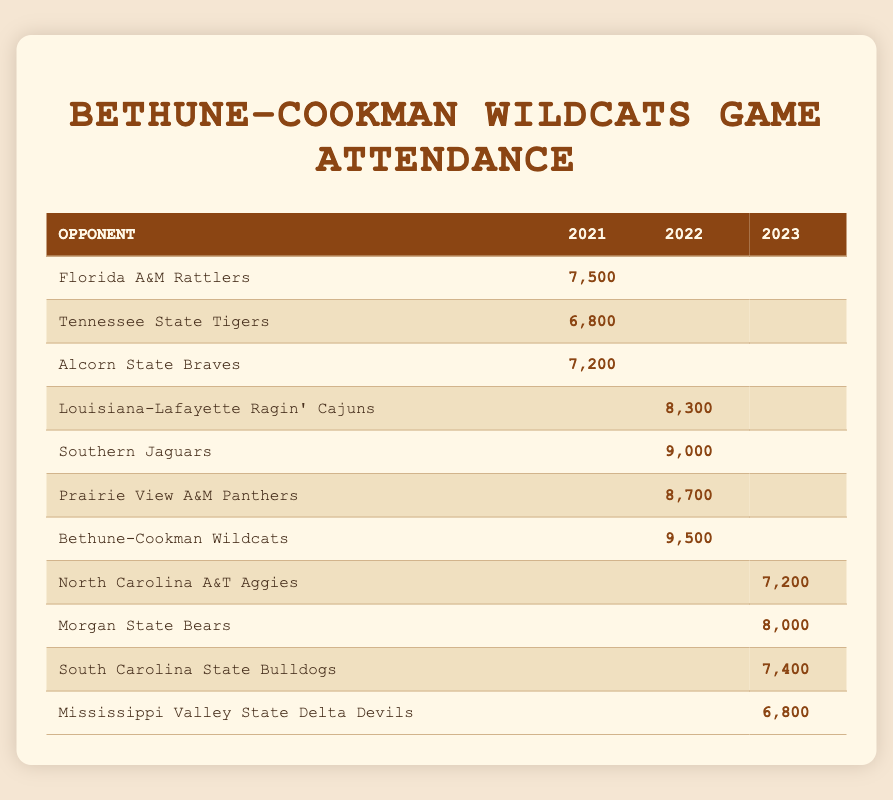What is the highest game attendance recorded in 2022? In the 2022 season, the attendance figures are 8,300 (Louisiana-Lafayette), 9,000 (Southern), 8,700 (Prairie View A&M), and 9,500 (Bethune-Cookman). The maximum attendance among these values is 9,500.
Answer: 9,500 Which opponent had the lowest attendance in 2021? Examining the 2021 attendance values, we have 7,500 (Florida A&M), 6,800 (Tennessee State), and 7,200 (Alcorn State). The lowest is 6,800 for Tennessee State.
Answer: 6,800 Calculate the average attendance across all games played in 2023. The attendances for 2023 are 7,200 (North Carolina A&T), 8,000 (Morgan State), 7,400 (South Carolina State), and 6,800 (Mississippi Valley State). Summing these gives 7,200 + 8,000 + 7,400 + 6,800 = 29,400. Dividing by the number of games (4) gives an average of 29,400 / 4 = 7,350.
Answer: 7,350 Did the attendance for Bethune-Cookman Wildcats increase from 2021 to 2022? In 2021, the Wildcats' game attendance is not listed, while in 2022 it is 9,500. Since there is no attendance for 2021 to compare against, we cannot confirm an increase.
Answer: No Which opponent played in both 2021 and 2022? Looking through the opponents, none of the teams listed for 2021 (Florida A&M, Tennessee State, Alcorn State) appear in 2022. Additionally, the only mention of Bethune-Cookman is in 2022, suggesting no opponent is common between these two years.
Answer: None 